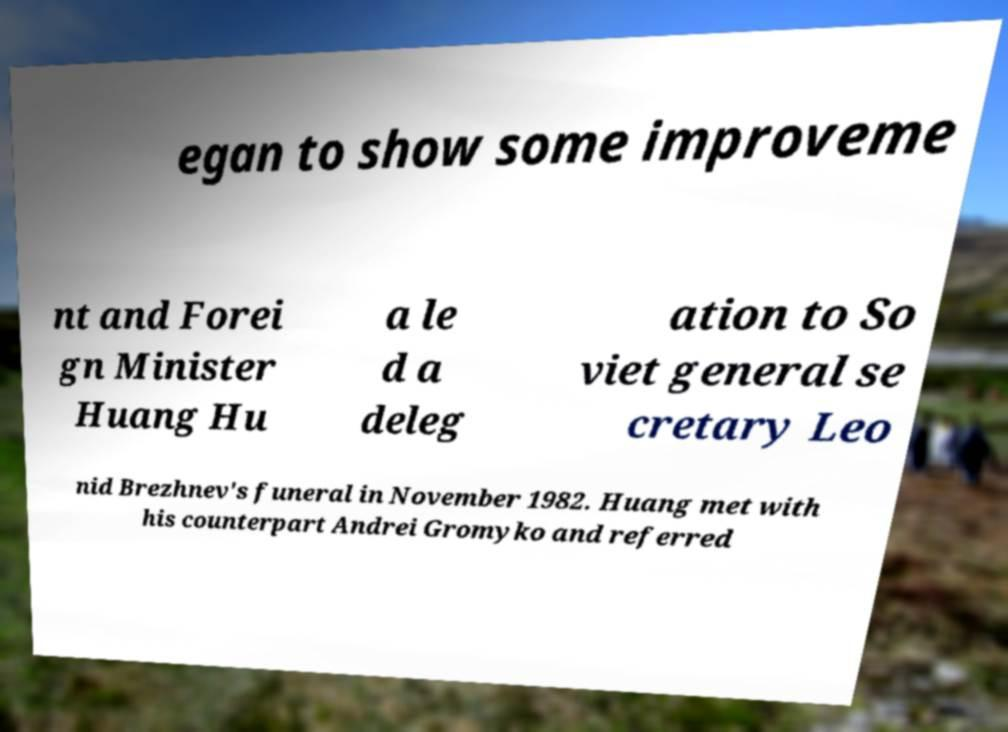Could you extract and type out the text from this image? egan to show some improveme nt and Forei gn Minister Huang Hu a le d a deleg ation to So viet general se cretary Leo nid Brezhnev's funeral in November 1982. Huang met with his counterpart Andrei Gromyko and referred 